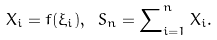Convert formula to latex. <formula><loc_0><loc_0><loc_500><loc_500>{ X _ { i } = f ( \xi _ { i } ) , \ S _ { n } = \sum \nolimits _ { i = 1 } ^ { n } X _ { i } . }</formula> 